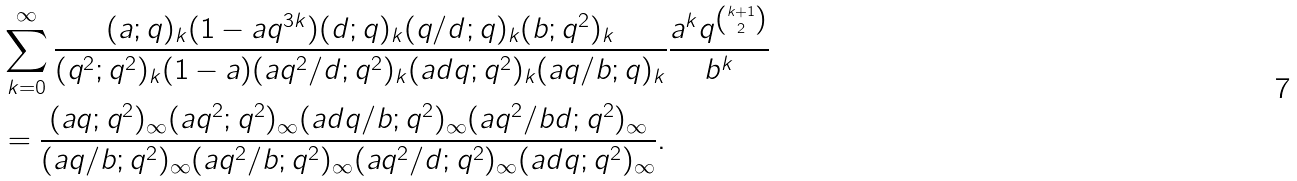<formula> <loc_0><loc_0><loc_500><loc_500>& \sum _ { k = 0 } ^ { \infty } \frac { ( a ; q ) _ { k } ( 1 - a q ^ { 3 k } ) ( d ; q ) _ { k } ( q / d ; q ) _ { k } ( b ; q ^ { 2 } ) _ { k } } { ( q ^ { 2 } ; q ^ { 2 } ) _ { k } ( 1 - a ) ( a q ^ { 2 } / d ; q ^ { 2 } ) _ { k } ( a d q ; q ^ { 2 } ) _ { k } ( a q / b ; q ) _ { k } } \frac { a ^ { k } q ^ { k + 1 \choose 2 } } { b ^ { k } } \\ & = \frac { ( a q ; q ^ { 2 } ) _ { \infty } ( a q ^ { 2 } ; q ^ { 2 } ) _ { \infty } ( a d q / b ; q ^ { 2 } ) _ { \infty } ( a q ^ { 2 } / b d ; q ^ { 2 } ) _ { \infty } } { ( a q / b ; q ^ { 2 } ) _ { \infty } ( a q ^ { 2 } / b ; q ^ { 2 } ) _ { \infty } ( a q ^ { 2 } / d ; q ^ { 2 } ) _ { \infty } ( a d q ; q ^ { 2 } ) _ { \infty } } .</formula> 